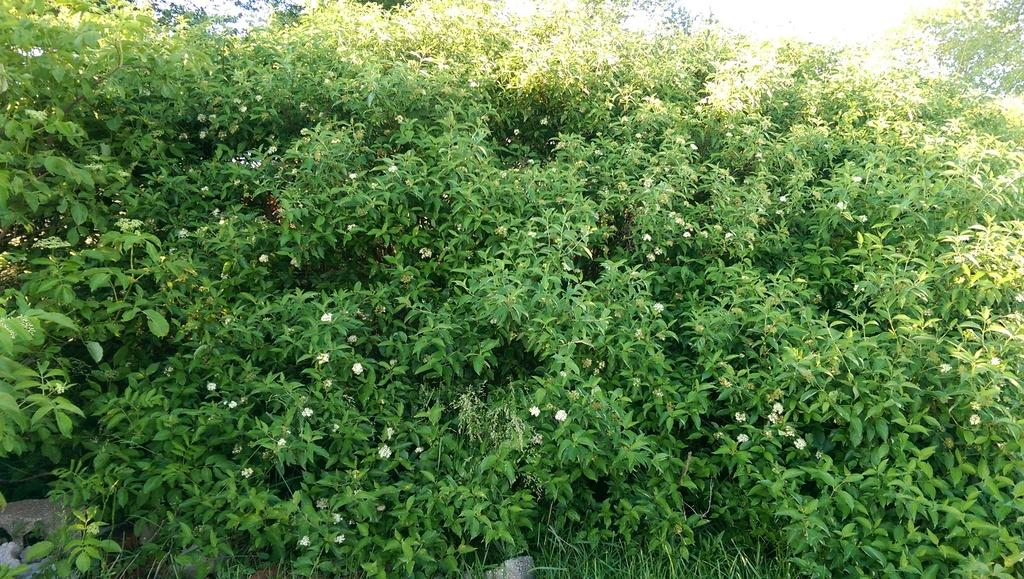What type of living organisms are present in the image? There are plants in the image. What color are the leaves of the plants? The leaves of the plants are green. What type of flowers are present on the plants? The plants have small white flowers. How many men are sitting on the fly in the image? There are no men or flies present in the image; it features plants with green leaves and small white flowers. 